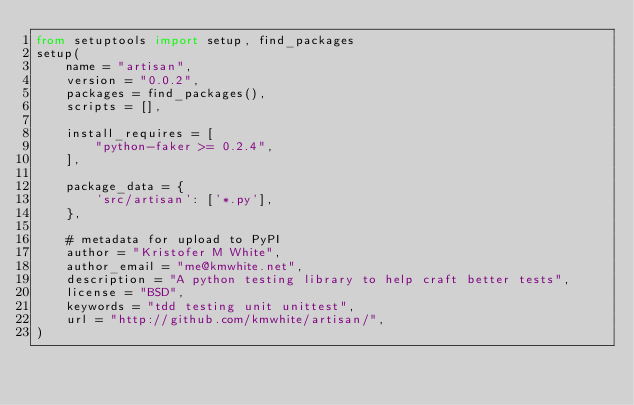Convert code to text. <code><loc_0><loc_0><loc_500><loc_500><_Python_>from setuptools import setup, find_packages
setup(
    name = "artisan",
    version = "0.0.2",
    packages = find_packages(),
    scripts = [],

    install_requires = [
        "python-faker >= 0.2.4",
    ],

    package_data = {
        'src/artisan': ['*.py'],
    },

    # metadata for upload to PyPI
    author = "Kristofer M White",
    author_email = "me@kmwhite.net",
    description = "A python testing library to help craft better tests",
    license = "BSD",
    keywords = "tdd testing unit unittest",
    url = "http://github.com/kmwhite/artisan/",
)
</code> 